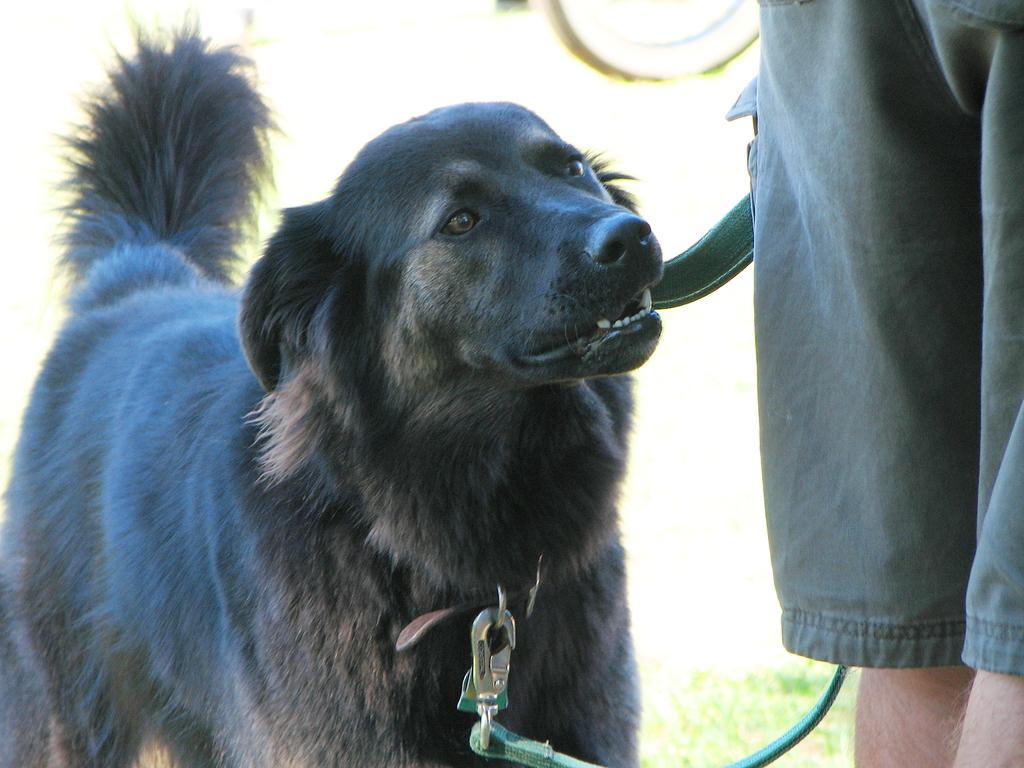In one or two sentences, can you explain what this image depicts? This picture is clicked outside. On the right corner we can see the legs of a person. On the left there is a black color dog, wearing a belt and standing. In the background we can see the grass and some other objects. 